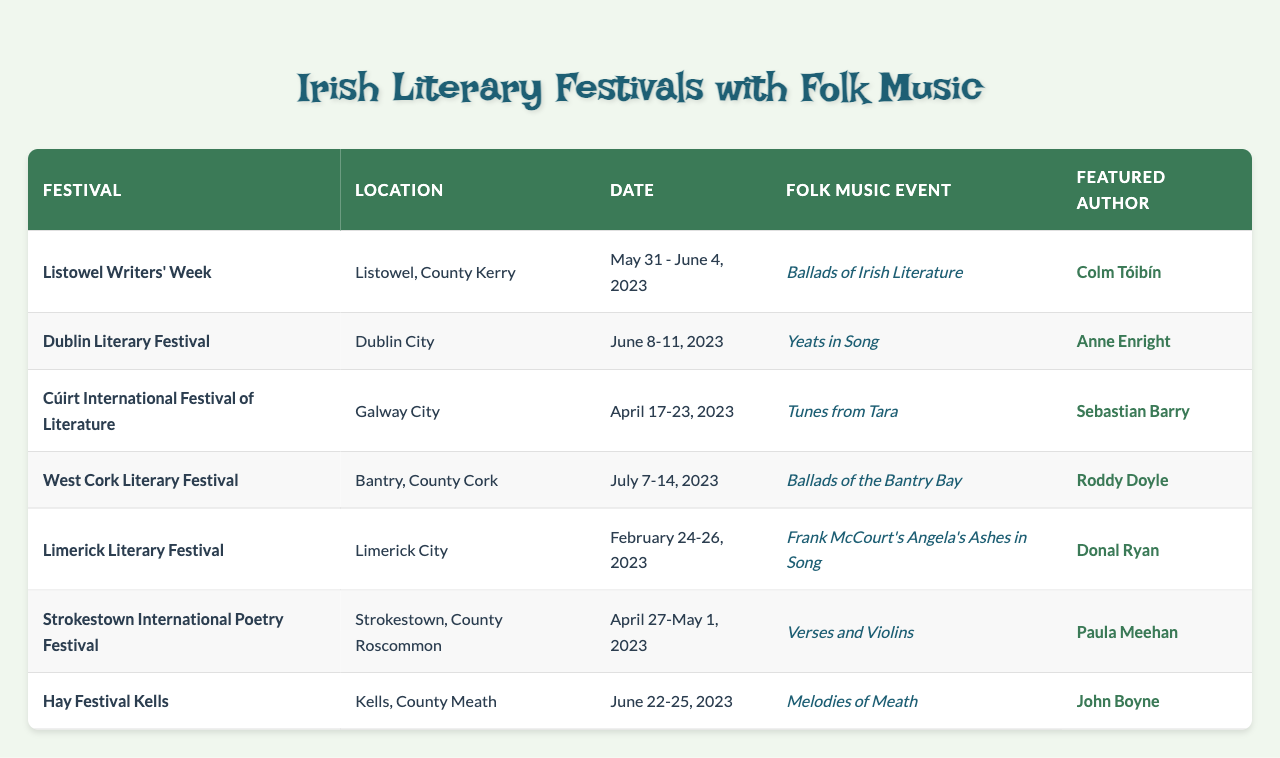What is the location of the Dublin Literary Festival? The table lists that the Dublin Literary Festival is located in Dublin City.
Answer: Dublin City Which folk music event takes place at the Listowel Writers' Week? The table indicates that the folk music event for the Listowel Writers' Week is "Ballads of Irish Literature."
Answer: Ballads of Irish Literature How many festivals feature folk music events in June 2023? The festivals in June 2023 are the Dublin Literary Festival (June 8-11) and Hay Festival Kells (June 22-25), totaling two festivals.
Answer: 2 Is Frank McCourt's work featured in any folk music events? Yes, the folk music event at the Limerick Literary Festival is based on Frank McCourt's "Angela's Ashes."
Answer: Yes What is the date range for the Cúirt International Festival of Literature? According to the table, the Cúirt International Festival of Literature occurs from April 17 to April 23, 2023.
Answer: April 17 - April 23, 2023 Which author is featured at the West Cork Literary Festival? The table specifies that Roddy Doyle is the featured author at the West Cork Literary Festival.
Answer: Roddy Doyle What is the most recent festival listed in the table? The most recent festival from the table is the Hay Festival Kells, occurring from June 22-25, 2023.
Answer: Hay Festival Kells Which festival features a folk music event called "Verses and Violins"? The Strokestown International Poetry Festival features the folk music event "Verses and Violins."
Answer: Strokestown International Poetry Festival Are all festivals listed in 2023? Yes, all the festivals mentioned in the table occur in the year 2023.
Answer: Yes Which festival has the earliest date listed? The earliest date listed in the table is for the Limerick Literary Festival, which takes place on February 24-26, 2023.
Answer: Limerick Literary Festival How many different locations are represented in the table? The locations listed are Listowel, Dublin City, Galway City, Bantry, Limerick City, Strokestown, and Kells, totaling seven different locations.
Answer: 7 